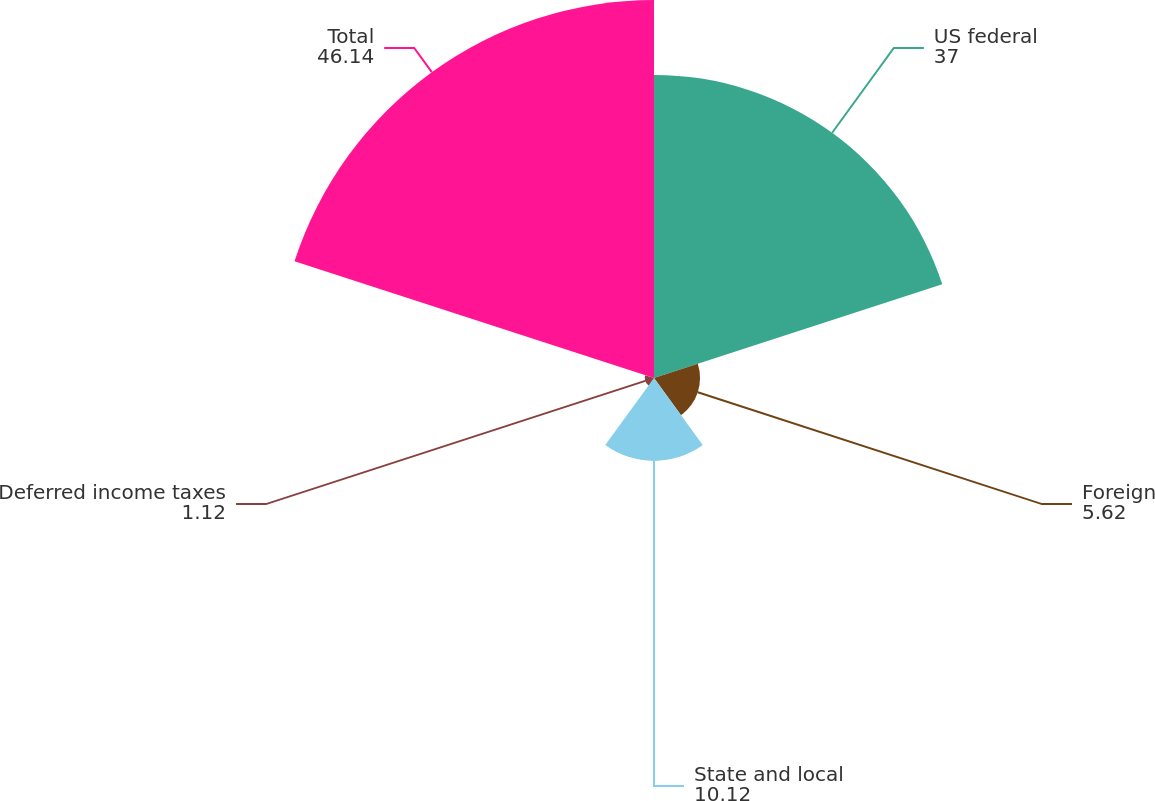Convert chart to OTSL. <chart><loc_0><loc_0><loc_500><loc_500><pie_chart><fcel>US federal<fcel>Foreign<fcel>State and local<fcel>Deferred income taxes<fcel>Total<nl><fcel>37.0%<fcel>5.62%<fcel>10.12%<fcel>1.12%<fcel>46.14%<nl></chart> 